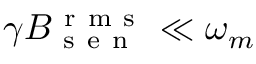Convert formula to latex. <formula><loc_0><loc_0><loc_500><loc_500>\gamma B _ { s e n } ^ { r m s } \ll \omega _ { m }</formula> 